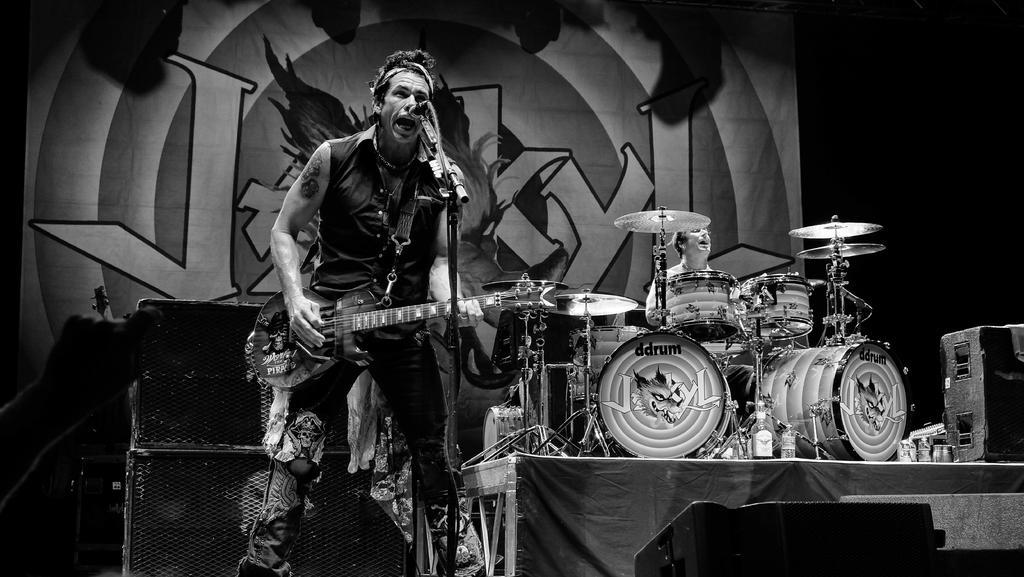Please provide a concise description of this image. In the center of the image there is a man playing guitar. There is a mic. In the background there is a man playing band. There is a speaker. 